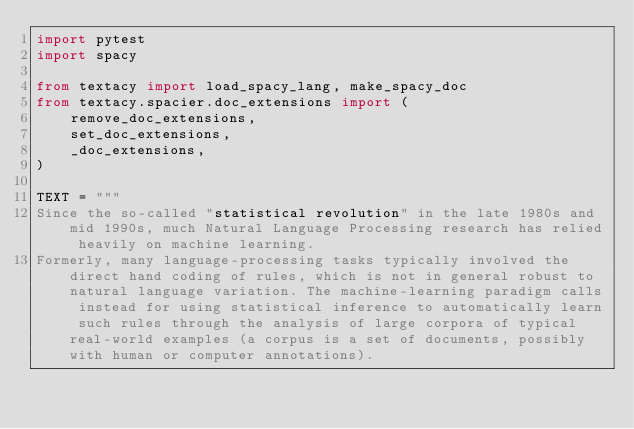<code> <loc_0><loc_0><loc_500><loc_500><_Python_>import pytest
import spacy

from textacy import load_spacy_lang, make_spacy_doc
from textacy.spacier.doc_extensions import (
    remove_doc_extensions,
    set_doc_extensions,
    _doc_extensions,
)

TEXT = """
Since the so-called "statistical revolution" in the late 1980s and mid 1990s, much Natural Language Processing research has relied heavily on machine learning.
Formerly, many language-processing tasks typically involved the direct hand coding of rules, which is not in general robust to natural language variation. The machine-learning paradigm calls instead for using statistical inference to automatically learn such rules through the analysis of large corpora of typical real-world examples (a corpus is a set of documents, possibly with human or computer annotations).</code> 